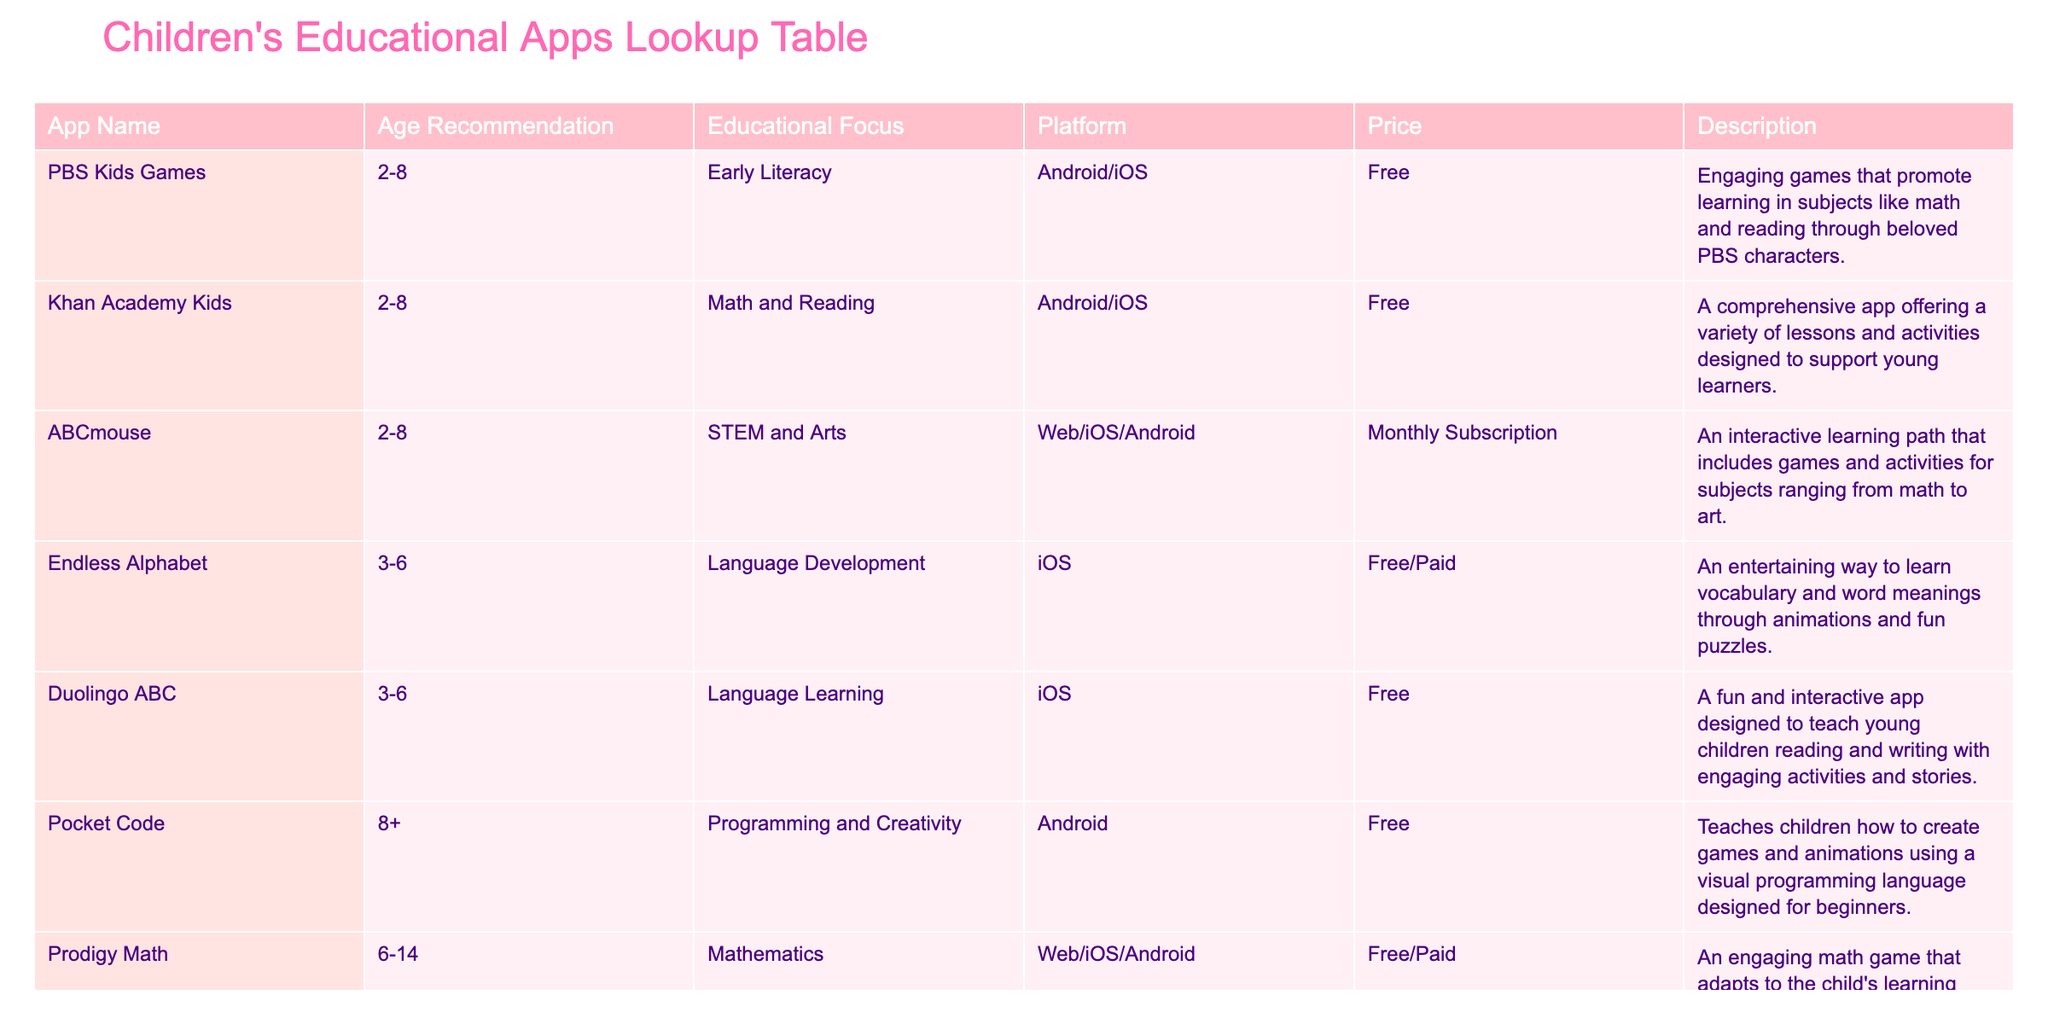What age range is recommended for PBS Kids Games? The table indicates that PBS Kids Games is recommended for children aged 2 to 8 years. You can find this information directly under the "Age Recommendation" column corresponding to the app name "PBS Kids Games."
Answer: 2-8 How many apps focus on Language Development? In the table, only one app is specifically focused on Language Development, which is Endless Alphabet. This can be verified by counting the entries under the "Educational Focus" column that match "Language Development."
Answer: 1 Are all apps for children aged 2-8 free? Looking at the price column for apps recommended for children aged 2-8, PBS Kids Games, Khan Academy Kids, and Endless Alphabet are free, while ABCmouse has a monthly subscription. Thus, not all of them are free.
Answer: No Which app has a programming focus and what is its age recommendation? The app that focuses on programming is Pocket Code, and it is recommended for children aged 8 and above, as stated in the "Age Recommendation" and "Educational Focus" columns.
Answer: Pocket Code, 8+ What is the average age range suggested for all apps in the table? The age recommendations for the apps are 2-8, 2-8, 2-8, 3-6, 3-6, and 8+. To find the average age range, we can calculate the average minimum (2, 2, 2, 3, 3, 8 gives an average of (2+2+2+3+3+8)/6 = 3.33) and the average maximum (8, 8, 8, 6, 6, and 8 gives an average of (8+8+8+6+6+8)/6 = 7.33). This places the average range approximately between the values rounding to 3-7.
Answer: Average range: 3-7 How many platforms are represented in the table? By examining the platform column, we see that there are three distinct platforms: Android, iOS, and Web. Counting these shows there are 3 unique platforms across the various apps.
Answer: 3 Is Prodigy Math available on iOS? Looking at the "Platform" column for Prodigy Math, it states that the app is available on Web, iOS, and Android. Therefore, it is indeed available on iOS.
Answer: Yes What educational focus combines STEM and Arts? The educational focus that combines both STEM and Arts is found in the app ABCmouse as stated in the "Educational Focus" column specifically for that app name.
Answer: STEM and Arts Which app has a cost associated that is not free? The app ABCmouse is the only one that has a monthly subscription cost associated with it, as indicated in the "Price" column. All other apps listed are free.
Answer: ABCmouse 